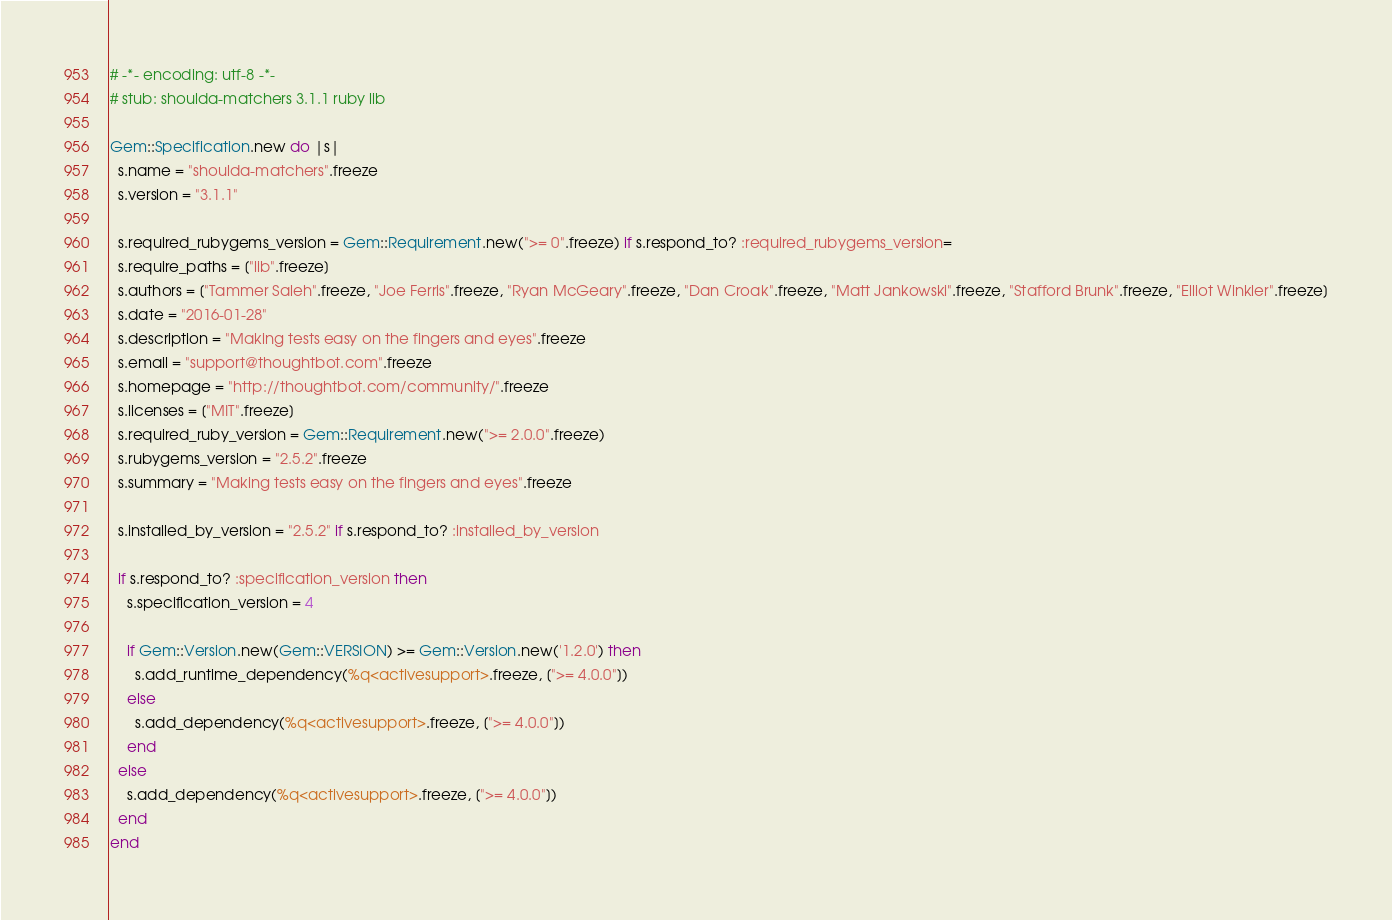<code> <loc_0><loc_0><loc_500><loc_500><_Ruby_># -*- encoding: utf-8 -*-
# stub: shoulda-matchers 3.1.1 ruby lib

Gem::Specification.new do |s|
  s.name = "shoulda-matchers".freeze
  s.version = "3.1.1"

  s.required_rubygems_version = Gem::Requirement.new(">= 0".freeze) if s.respond_to? :required_rubygems_version=
  s.require_paths = ["lib".freeze]
  s.authors = ["Tammer Saleh".freeze, "Joe Ferris".freeze, "Ryan McGeary".freeze, "Dan Croak".freeze, "Matt Jankowski".freeze, "Stafford Brunk".freeze, "Elliot Winkler".freeze]
  s.date = "2016-01-28"
  s.description = "Making tests easy on the fingers and eyes".freeze
  s.email = "support@thoughtbot.com".freeze
  s.homepage = "http://thoughtbot.com/community/".freeze
  s.licenses = ["MIT".freeze]
  s.required_ruby_version = Gem::Requirement.new(">= 2.0.0".freeze)
  s.rubygems_version = "2.5.2".freeze
  s.summary = "Making tests easy on the fingers and eyes".freeze

  s.installed_by_version = "2.5.2" if s.respond_to? :installed_by_version

  if s.respond_to? :specification_version then
    s.specification_version = 4

    if Gem::Version.new(Gem::VERSION) >= Gem::Version.new('1.2.0') then
      s.add_runtime_dependency(%q<activesupport>.freeze, [">= 4.0.0"])
    else
      s.add_dependency(%q<activesupport>.freeze, [">= 4.0.0"])
    end
  else
    s.add_dependency(%q<activesupport>.freeze, [">= 4.0.0"])
  end
end
</code> 